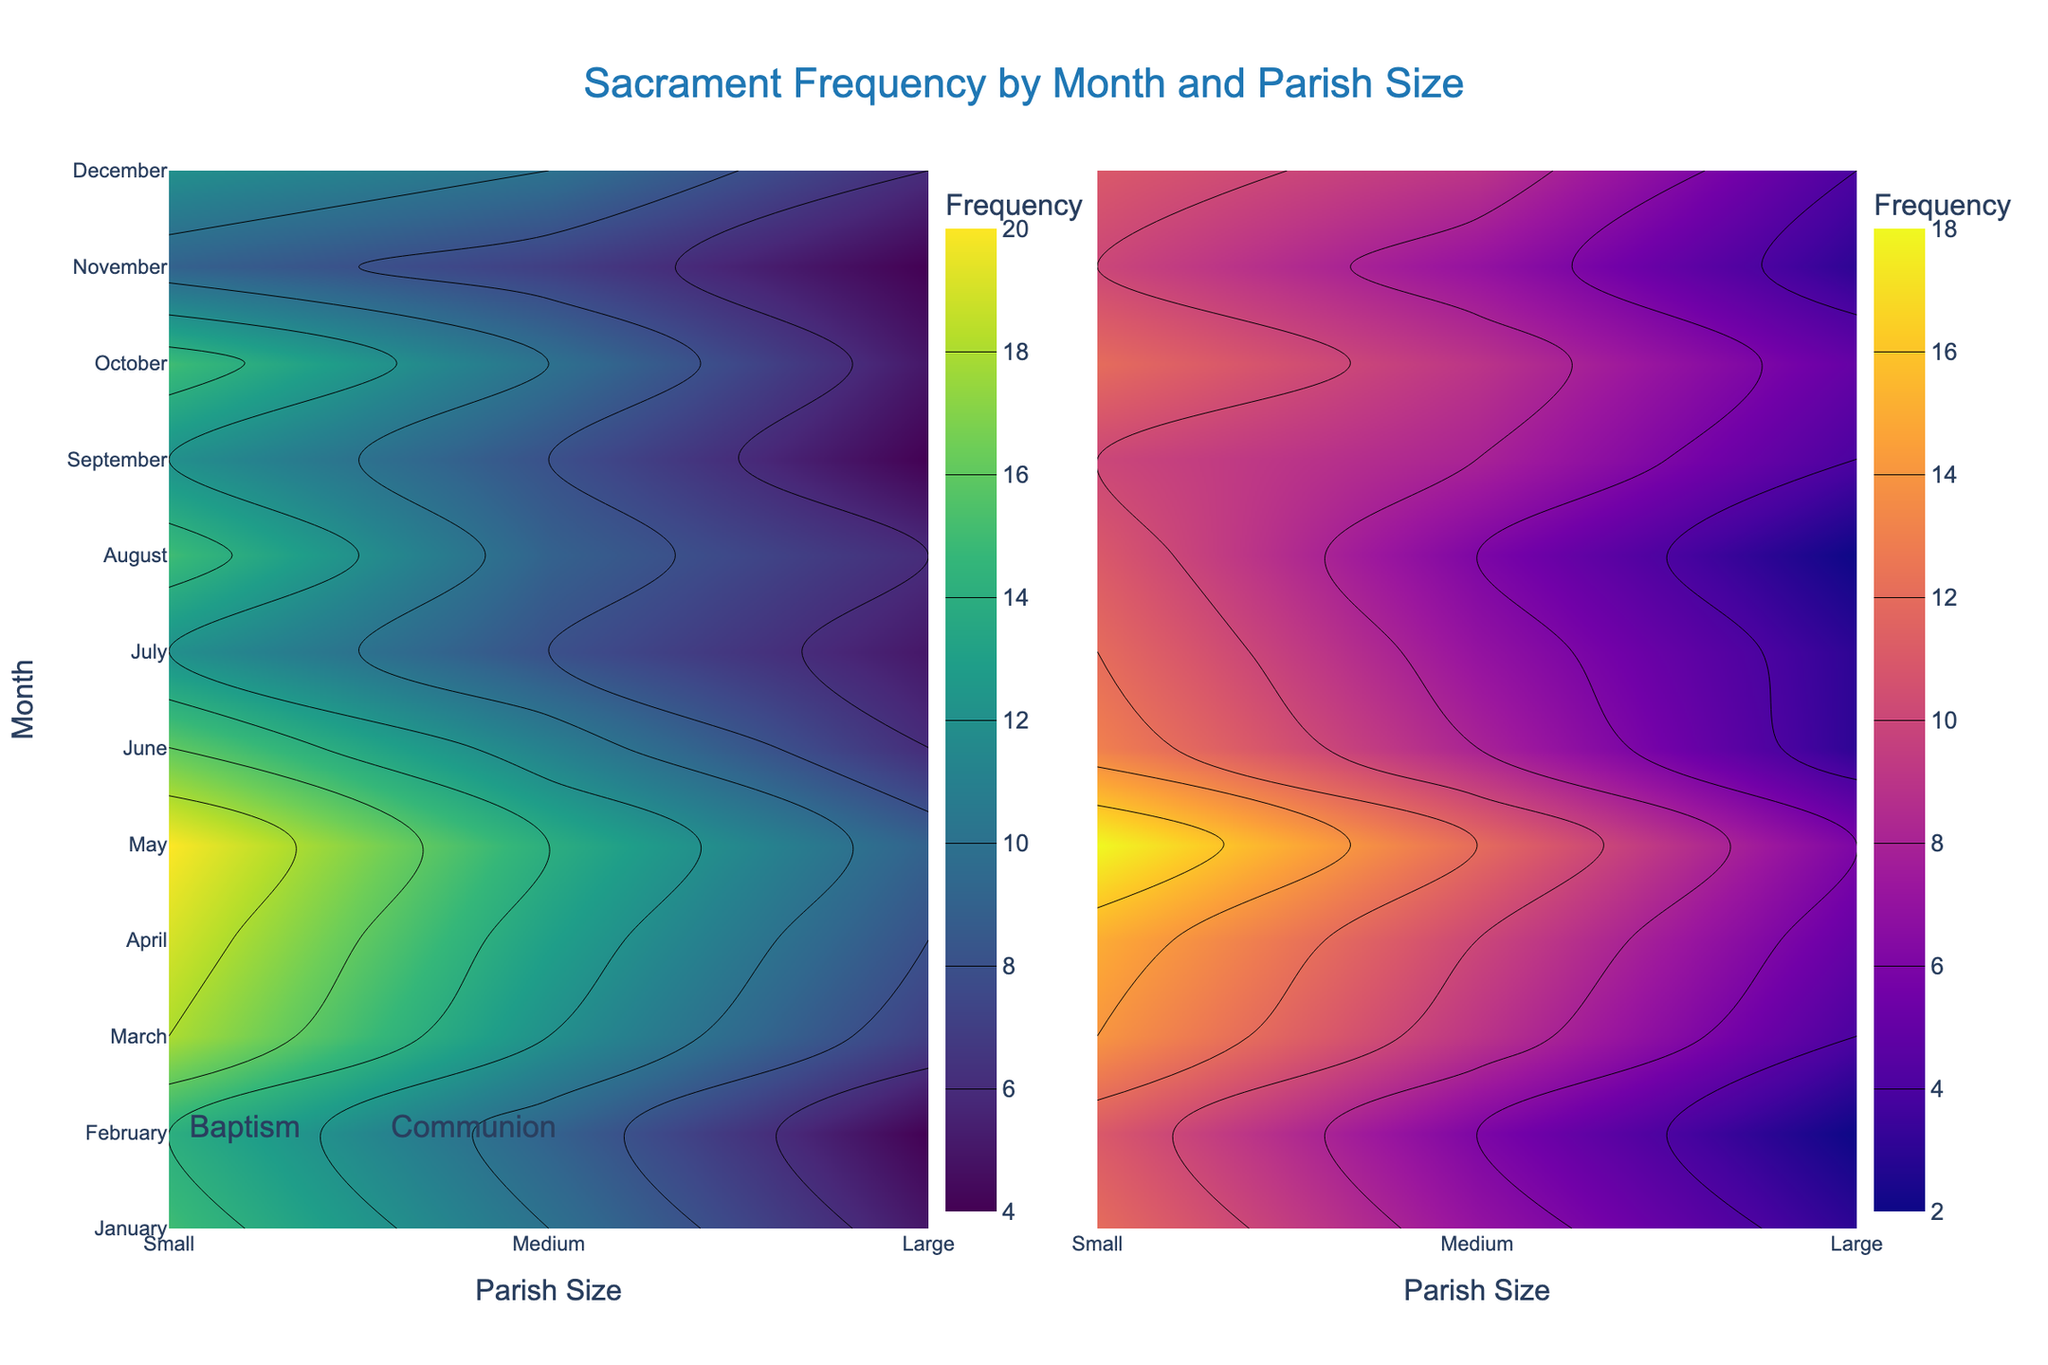What is the title of the figure? The title of the figure is located at the top center, typically in larger font size to grab attention. From the description, the title should be "Sacrament Frequency by Month and Parish Size".
Answer: Sacrament Frequency by Month and Parish Size What are the two sacraments shown in this figure? The contour plot represents two subplots, one for each sacrament, likely labeled on top of each subplot. Based on the data, the sacraments are Baptism and Communion.
Answer: Baptism and Communion Which parish size has the highest frequency of Baptisms in May? Looking at the "Baptism" subplot, locate May on the y-axis and find the peak on the contour map along the parish sizes. According to the data, the "Large" parish size has the highest frequency in May.
Answer: Large What months have the highest frequency for Communion in small parishes? Find the "Communion" subplot and trace the "Small" parish size along the x-axis. The highest frequency will be seen at the brightest or darkest spots depending on the color scale. Based on the data, May and October stand out.
Answer: May, October How does the frequency of Baptisms in large parishes change from January to December? Trace along the y-axis for the Large parish size in the "Baptism" subplot. Identify if the contour colors (indicating frequency) get lighter or darker. There is a mix of ups and downs, but December has lower frequency compared to the middle of the year.
Answer: Decreases from peaks in the middle Compare the frequencies of Communion in Medium vs. Large parishes in November. In the "Communion" subplot, find November on the y-axis and look at the frequencies for Medium and Large. Based on the data, the Medium parish has a frequency of 7, while the Large parish has a frequency of 10.
Answer: Large > Medium In which month is the contrast between small and large parish frequencies for Baptism the greatest? Examine the "Baptism" subplot and compare the difference in contour colors between Small and Large parish sizes for all months. From the data, May shows the largest difference (9 for Small vs. 20 for Large).
Answer: May What is the average frequency of Baptisms in Medium parishes from January to December? Sum up the monthly frequencies for Medium parishes in the "Baptism" data (10 in January, 9 in February, etc.) and divide by 12. The total is 143, so 143/12 is approximately 11.92.
Answer: 11.92 What month shows the lowest frequency for both Baptism and Communion across all parish sizes? Identify the common month with the lowest frequency by scanning both subplots. November, with Baptisms (4, 7, 9) and Communions (3, 7, 10), appears to have the lowest numbers overall.
Answer: November Which subplot uses the Viridis colorscale, and which uses Plasma? Referring to the coding details, the contour plot for Baptisms uses the Viridis colorscale and the contour plot for Communion uses the Plasma colorscale. Viridis appears to the left and Plasma to the right given the colorbars' x position.
Answer: Baptism: Viridis, Communion: Plasma 